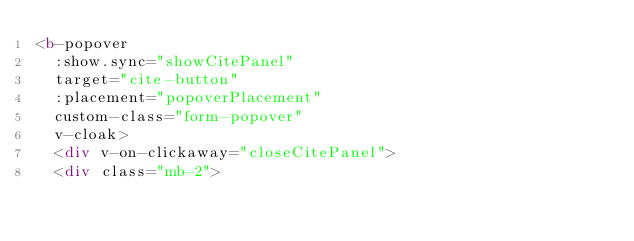<code> <loc_0><loc_0><loc_500><loc_500><_HTML_><b-popover
  :show.sync="showCitePanel"
  target="cite-button"
  :placement="popoverPlacement"
  custom-class="form-popover"
  v-cloak>
  <div v-on-clickaway="closeCitePanel">
  <div class="mb-2"></code> 